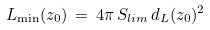Convert formula to latex. <formula><loc_0><loc_0><loc_500><loc_500>L _ { \min } ( z _ { 0 } ) \, = \, 4 \pi \, S _ { l i m } \, d _ { L } ( z _ { 0 } ) ^ { 2 } \,</formula> 